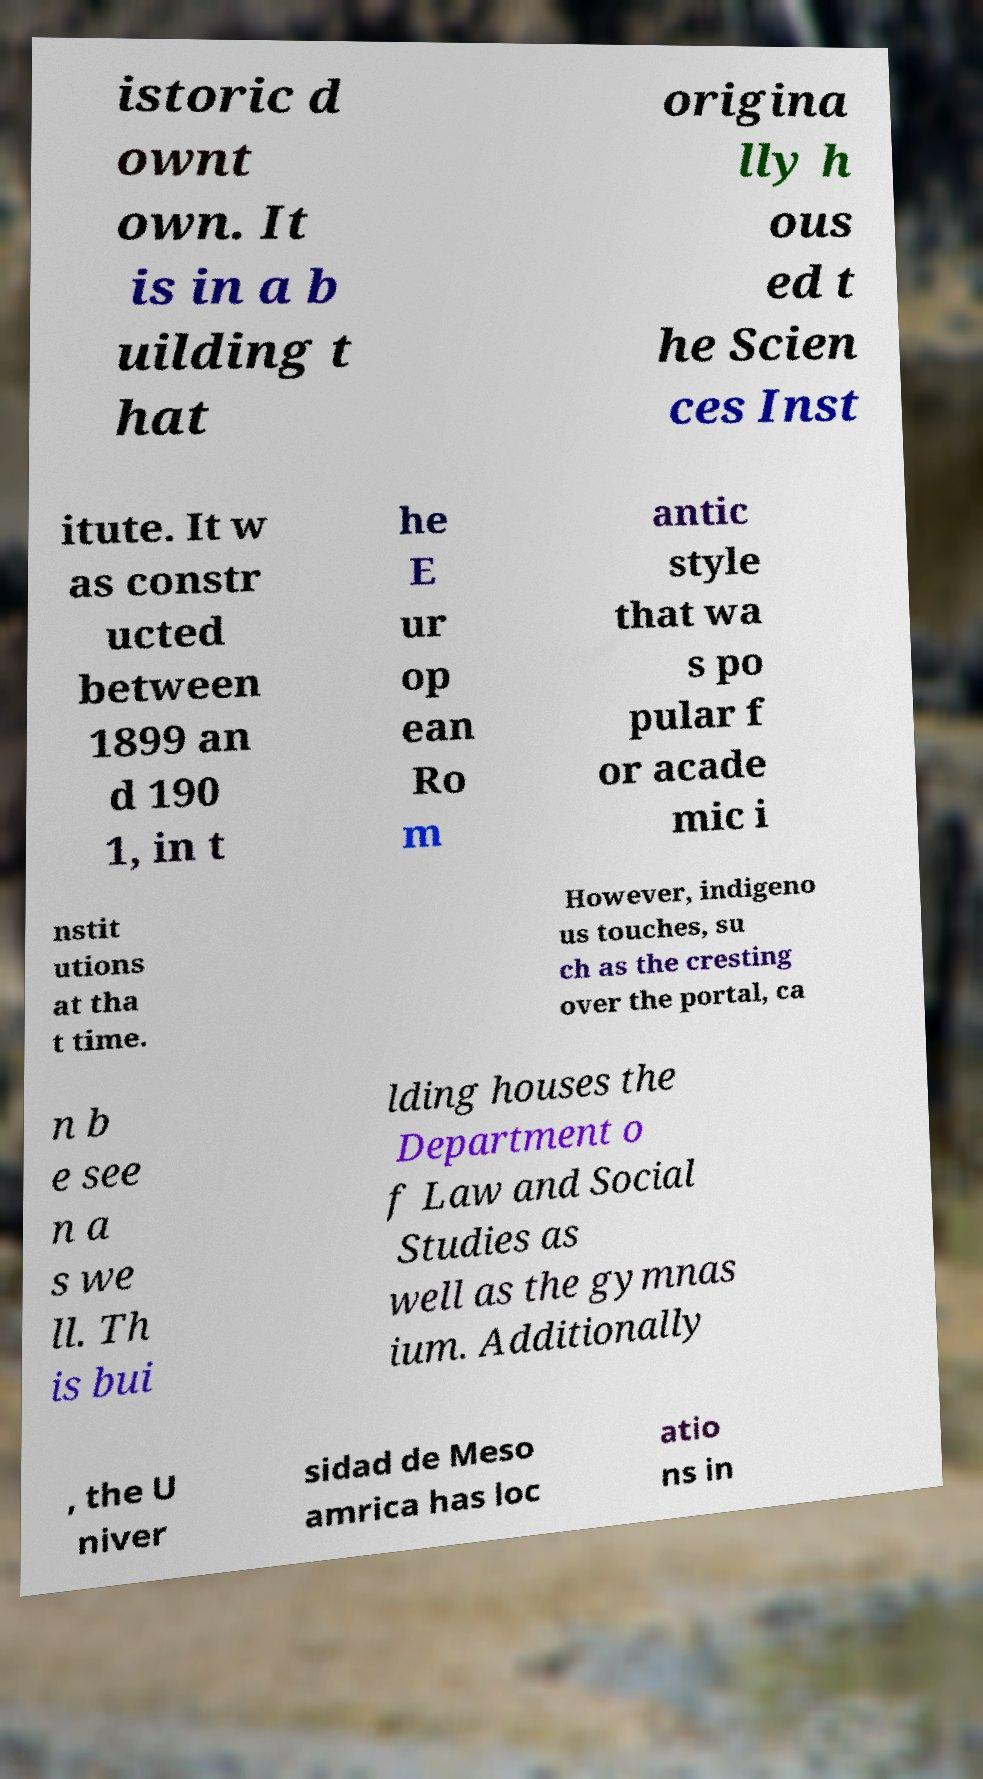I need the written content from this picture converted into text. Can you do that? istoric d ownt own. It is in a b uilding t hat origina lly h ous ed t he Scien ces Inst itute. It w as constr ucted between 1899 an d 190 1, in t he E ur op ean Ro m antic style that wa s po pular f or acade mic i nstit utions at tha t time. However, indigeno us touches, su ch as the cresting over the portal, ca n b e see n a s we ll. Th is bui lding houses the Department o f Law and Social Studies as well as the gymnas ium. Additionally , the U niver sidad de Meso amrica has loc atio ns in 